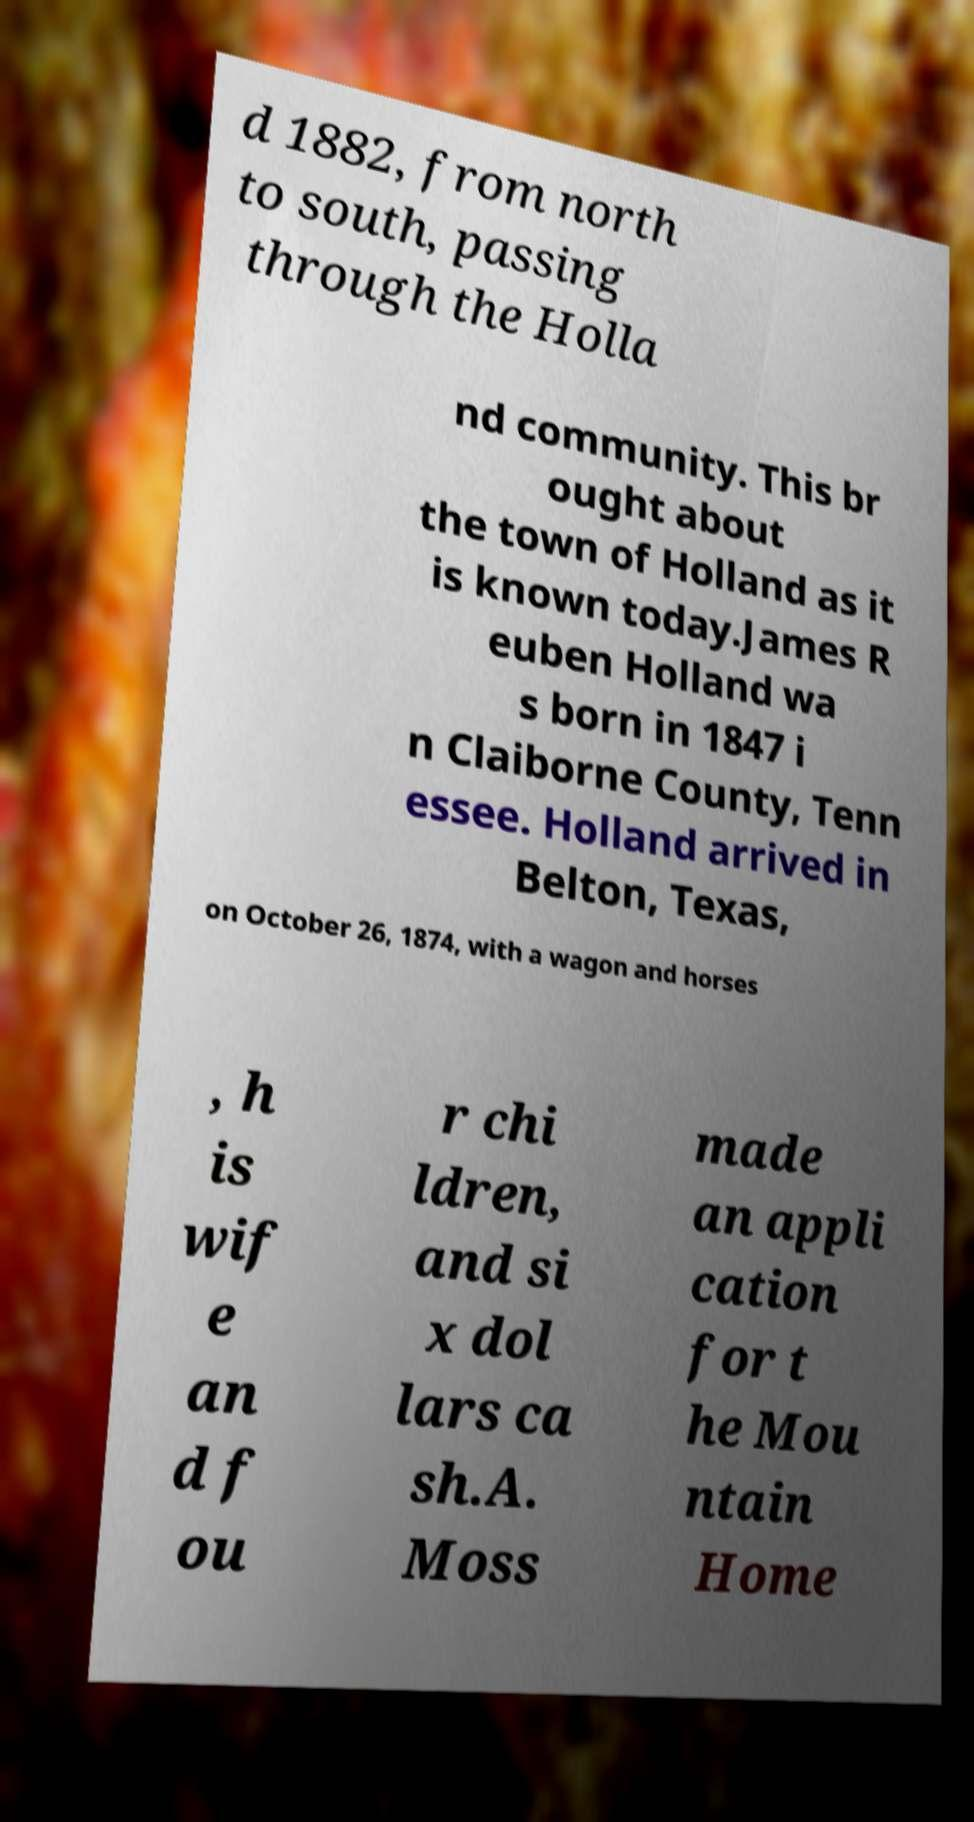Could you extract and type out the text from this image? d 1882, from north to south, passing through the Holla nd community. This br ought about the town of Holland as it is known today.James R euben Holland wa s born in 1847 i n Claiborne County, Tenn essee. Holland arrived in Belton, Texas, on October 26, 1874, with a wagon and horses , h is wif e an d f ou r chi ldren, and si x dol lars ca sh.A. Moss made an appli cation for t he Mou ntain Home 